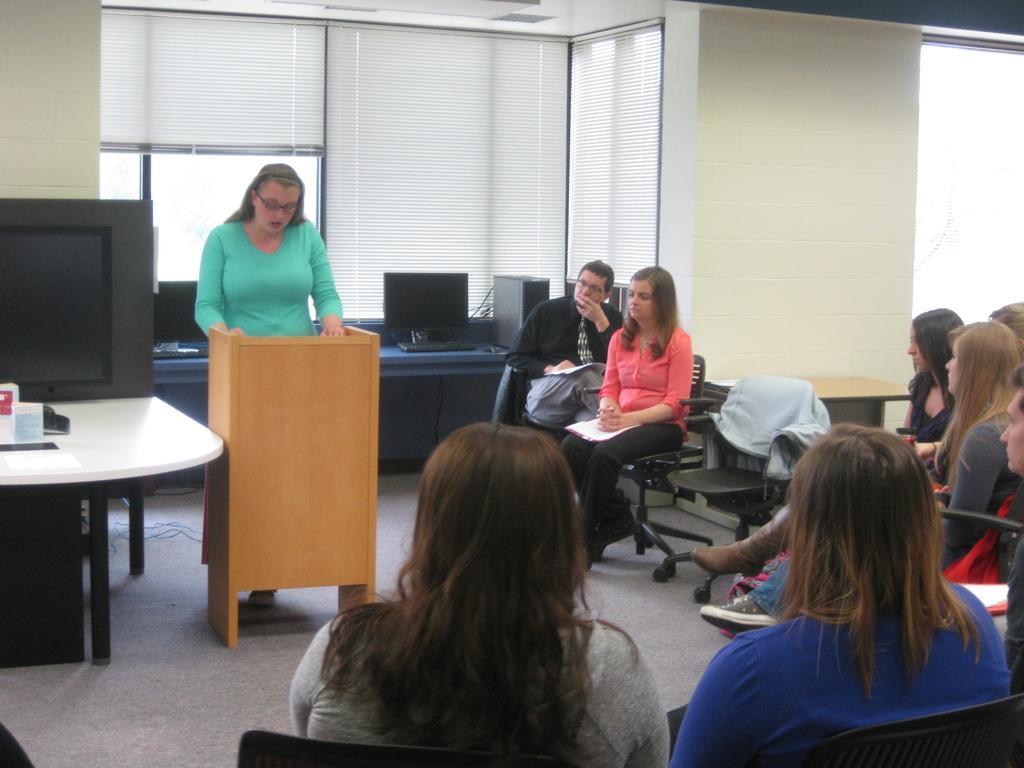Could you give a brief overview of what you see in this image? In this picture we can see some people sitting on chairs, there is a woman standing in front of a podium, in the background we can see desk, there are two monitors, a keyboard and a CPU present on the desk, on the left side we can see a table, we can see monitor here, in the background there are window blinds. 